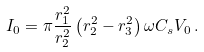<formula> <loc_0><loc_0><loc_500><loc_500>I _ { 0 } = \pi \frac { r _ { 1 } ^ { 2 } } { r _ { 2 } ^ { 2 } } \left ( r _ { 2 } ^ { 2 } - r _ { 3 } ^ { 2 } \right ) \omega C _ { s } V _ { 0 } \, .</formula> 